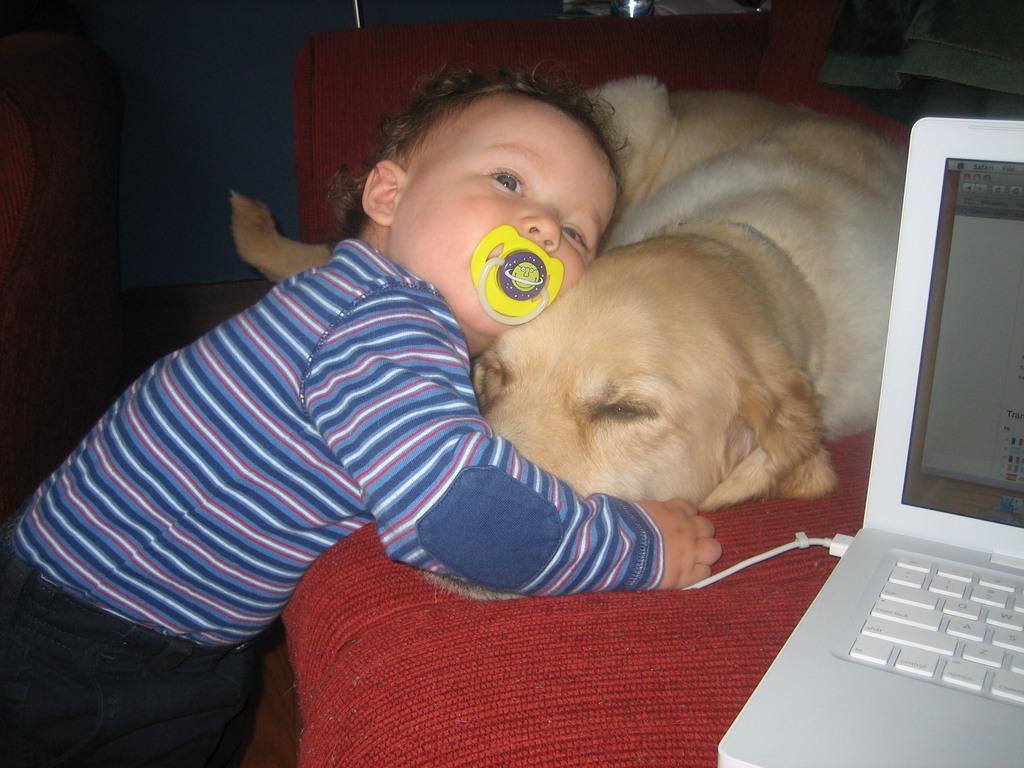Please provide a concise description of this image. Bottom left side of the image a kid is standing and holding a dog. In the middle of the image there is a couch. Bottom right side of the image there is a laptop on the couch. 